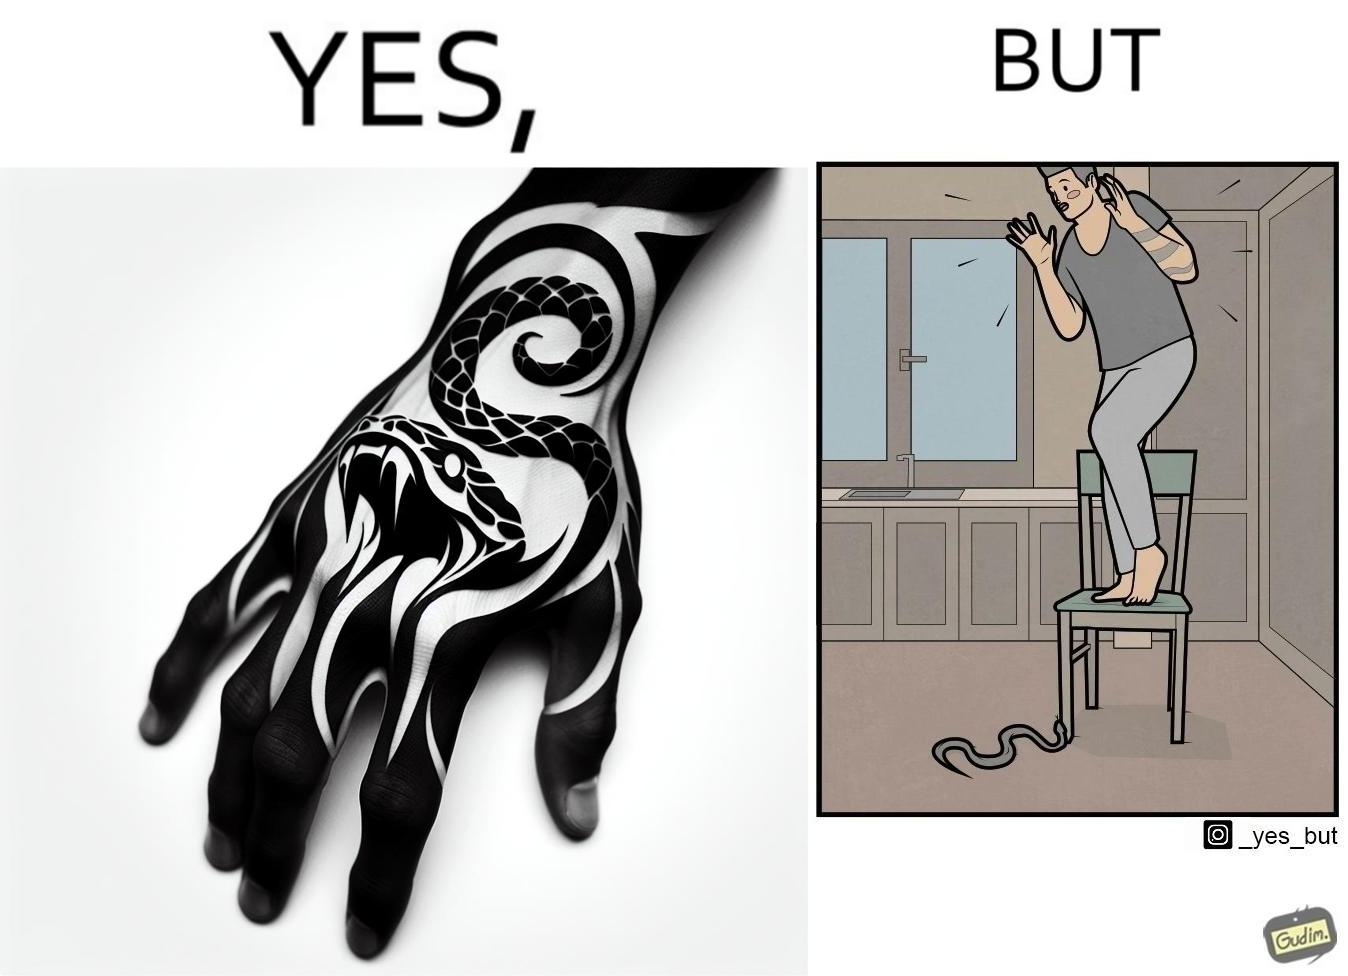Describe what you see in the left and right parts of this image. In the left part of the image: a tattoo of a snake with its mouth wide open on someone's hand In the right part of the image: a person standing on a chair trying save himself from the attack of snake and the snake is probably trying to climb up the chair 